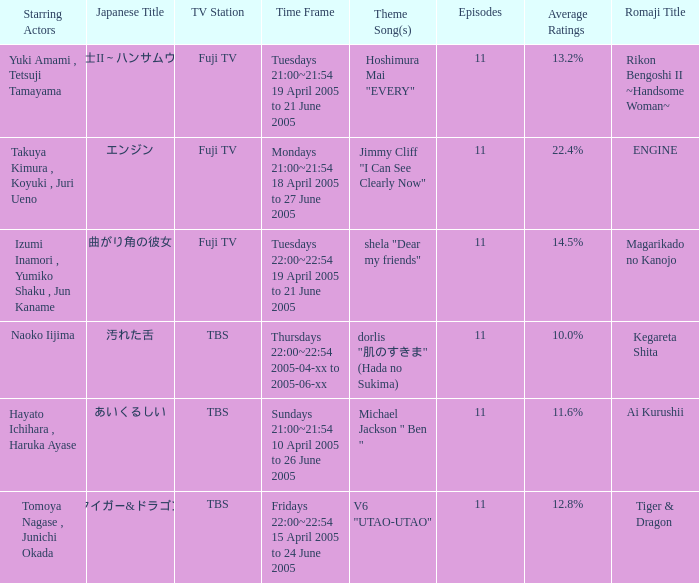I'm looking to parse the entire table for insights. Could you assist me with that? {'header': ['Starring Actors', 'Japanese Title', 'TV Station', 'Time Frame', 'Theme Song(s)', 'Episodes', 'Average Ratings', 'Romaji Title'], 'rows': [['Yuki Amami , Tetsuji Tamayama', '離婚弁護士II～ハンサムウーマン～', 'Fuji TV', 'Tuesdays 21:00~21:54 19 April 2005 to 21 June 2005', 'Hoshimura Mai "EVERY"', '11', '13.2%', 'Rikon Bengoshi II ~Handsome Woman~'], ['Takuya Kimura , Koyuki , Juri Ueno', 'エンジン', 'Fuji TV', 'Mondays 21:00~21:54 18 April 2005 to 27 June 2005', 'Jimmy Cliff "I Can See Clearly Now"', '11', '22.4%', 'ENGINE'], ['Izumi Inamori , Yumiko Shaku , Jun Kaname', '曲がり角の彼女', 'Fuji TV', 'Tuesdays 22:00~22:54 19 April 2005 to 21 June 2005', 'shela "Dear my friends"', '11', '14.5%', 'Magarikado no Kanojo'], ['Naoko Iijima', '汚れた舌', 'TBS', 'Thursdays 22:00~22:54 2005-04-xx to 2005-06-xx', 'dorlis "肌のすきま" (Hada no Sukima)', '11', '10.0%', 'Kegareta Shita'], ['Hayato Ichihara , Haruka Ayase', 'あいくるしい', 'TBS', 'Sundays 21:00~21:54 10 April 2005 to 26 June 2005', 'Michael Jackson " Ben "', '11', '11.6%', 'Ai Kurushii'], ['Tomoya Nagase , Junichi Okada', 'タイガー&ドラゴン', 'TBS', 'Fridays 22:00~22:54 15 April 2005 to 24 June 2005', 'V6 "UTAO-UTAO"', '11', '12.8%', 'Tiger & Dragon']]} What is the title with an average rating of 22.4%? ENGINE. 